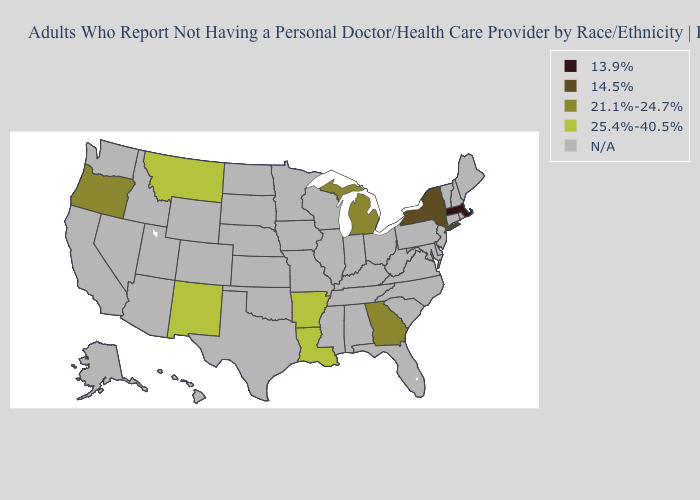Name the states that have a value in the range 21.1%-24.7%?
Answer briefly. Georgia, Michigan, Oregon. Does Oregon have the lowest value in the West?
Concise answer only. Yes. Does the first symbol in the legend represent the smallest category?
Give a very brief answer. Yes. What is the lowest value in the Northeast?
Concise answer only. 13.9%. Does Oregon have the lowest value in the West?
Quick response, please. Yes. What is the value of Wyoming?
Concise answer only. N/A. Does Arkansas have the highest value in the USA?
Short answer required. Yes. What is the value of New Mexico?
Write a very short answer. 25.4%-40.5%. Is the legend a continuous bar?
Concise answer only. No. Is the legend a continuous bar?
Concise answer only. No. 